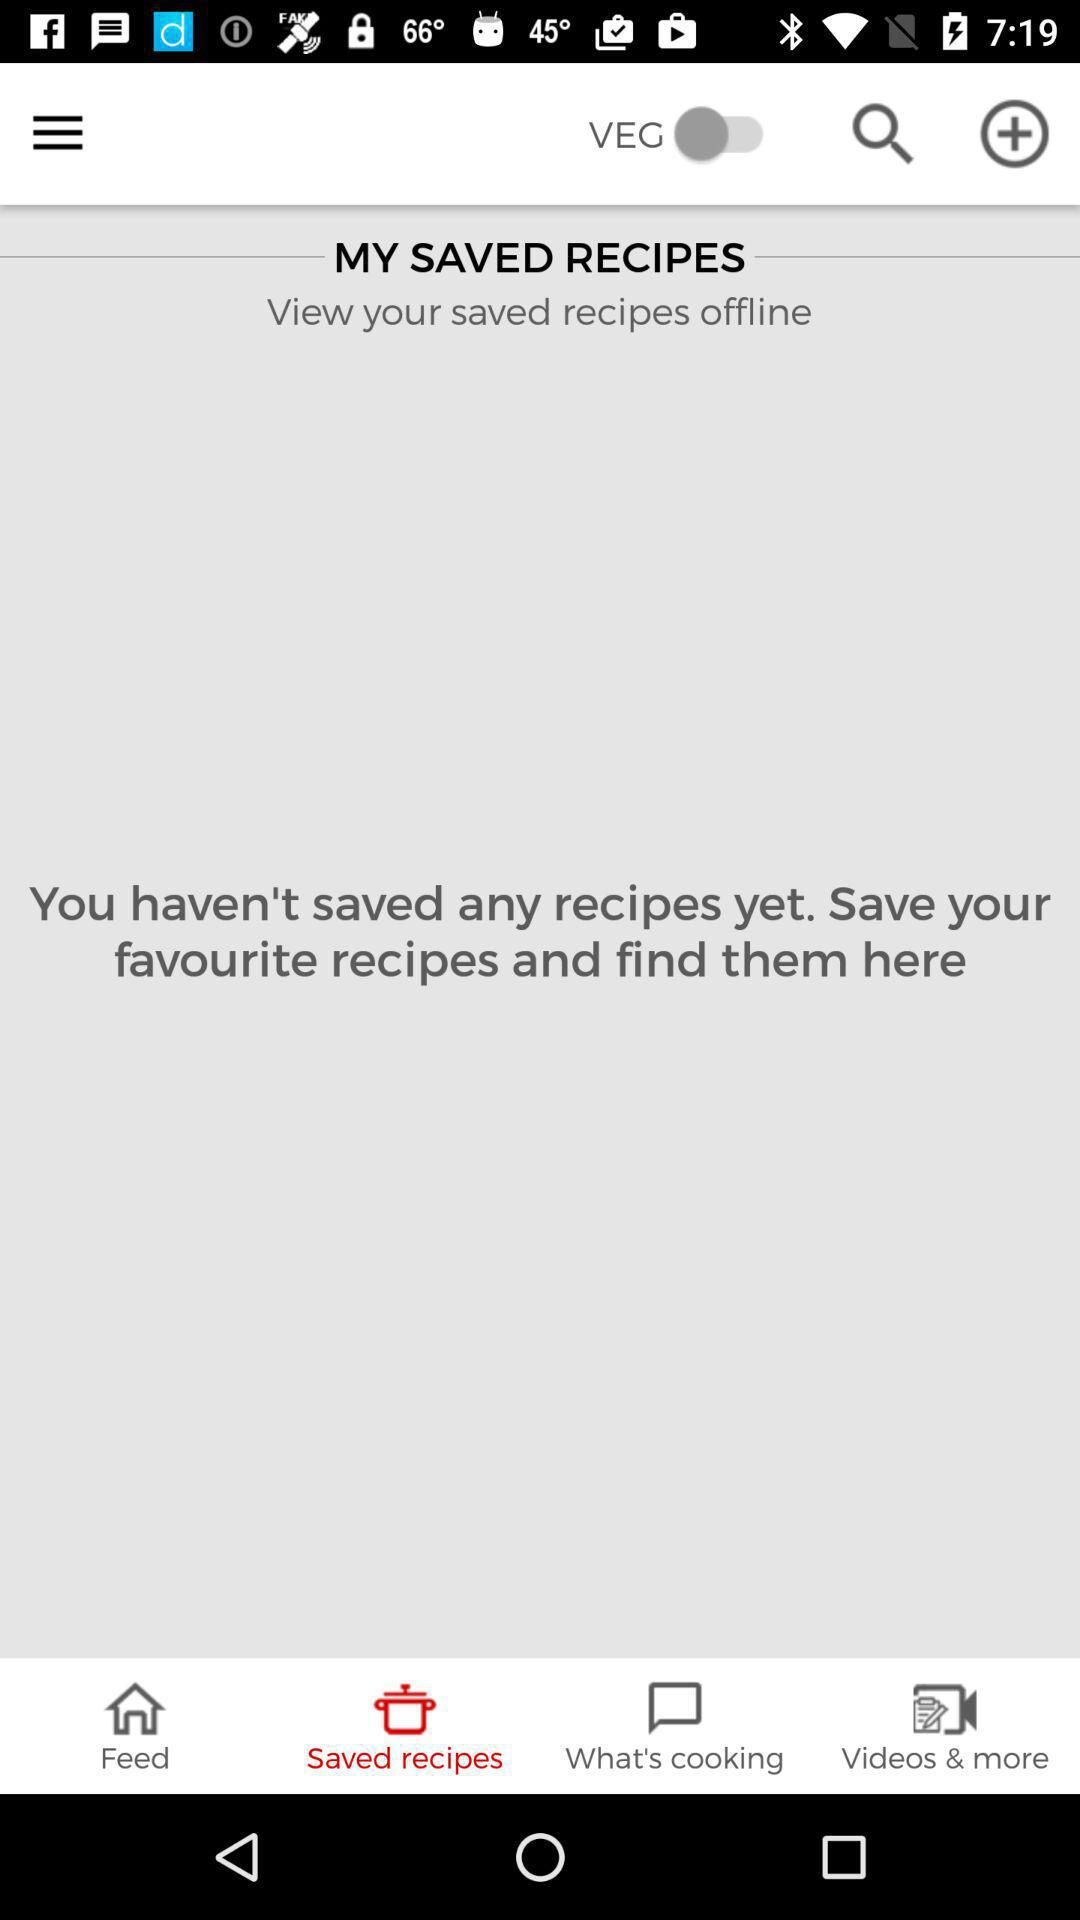How many recipes have I saved?
Answer the question using a single word or phrase. 0 